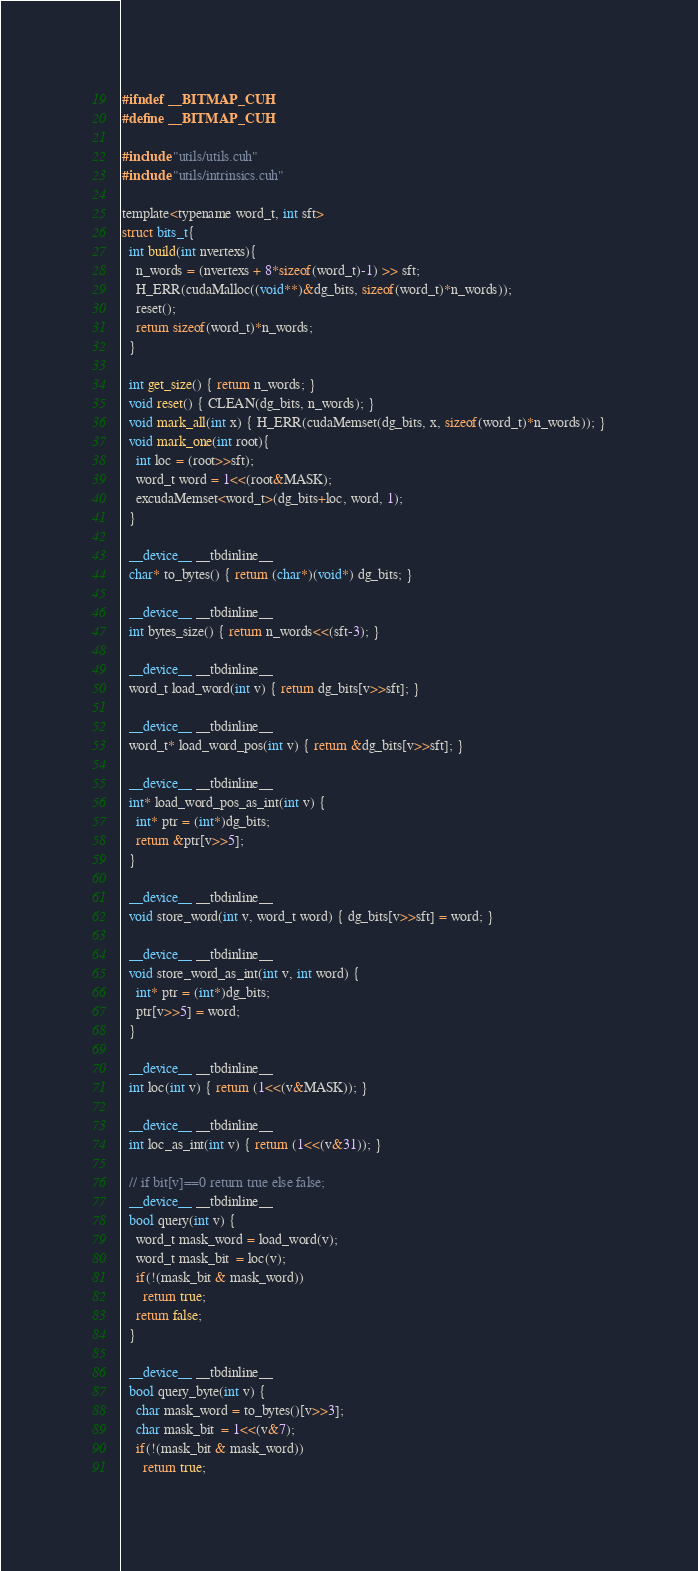<code> <loc_0><loc_0><loc_500><loc_500><_Cuda_>#ifndef __BITMAP_CUH
#define __BITMAP_CUH

#include "utils/utils.cuh"
#include "utils/intrinsics.cuh"

template<typename word_t, int sft>
struct bits_t{
  int build(int nvertexs){
    n_words = (nvertexs + 8*sizeof(word_t)-1) >> sft;
    H_ERR(cudaMalloc((void**)&dg_bits, sizeof(word_t)*n_words));
    reset();
    return sizeof(word_t)*n_words;
  }

  int get_size() { return n_words; }
  void reset() { CLEAN(dg_bits, n_words); }
  void mark_all(int x) { H_ERR(cudaMemset(dg_bits, x, sizeof(word_t)*n_words)); }
  void mark_one(int root){
    int loc = (root>>sft);
    word_t word = 1<<(root&MASK);
    excudaMemset<word_t>(dg_bits+loc, word, 1);
  }

  __device__ __tbdinline__
  char* to_bytes() { return (char*)(void*) dg_bits; }
  
  __device__ __tbdinline__
  int bytes_size() { return n_words<<(sft-3); }

  __device__ __tbdinline__
  word_t load_word(int v) { return dg_bits[v>>sft]; }

  __device__ __tbdinline__
  word_t* load_word_pos(int v) { return &dg_bits[v>>sft]; }

  __device__ __tbdinline__
  int* load_word_pos_as_int(int v) { 
    int* ptr = (int*)dg_bits;
    return &ptr[v>>5]; 
  }

  __device__ __tbdinline__
  void store_word(int v, word_t word) { dg_bits[v>>sft] = word; }

  __device__ __tbdinline__
  void store_word_as_int(int v, int word) { 
    int* ptr = (int*)dg_bits;
    ptr[v>>5] = word; 
  }

  __device__ __tbdinline__
  int loc(int v) { return (1<<(v&MASK)); }

  __device__ __tbdinline__
  int loc_as_int(int v) { return (1<<(v&31)); }

  // if bit[v]==0 return true else false;
  __device__ __tbdinline__
  bool query(int v) {
    word_t mask_word = load_word(v);
    word_t mask_bit  = loc(v);
    if(!(mask_bit & mask_word))
      return true;
    return false;
  }

  __device__ __tbdinline__
  bool query_byte(int v) {
    char mask_word = to_bytes()[v>>3];
    char mask_bit  = 1<<(v&7);
    if(!(mask_bit & mask_word))
      return true;</code> 